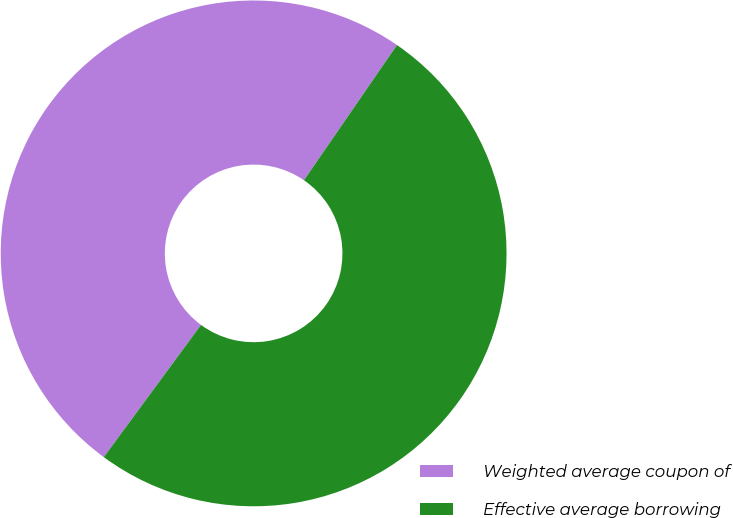<chart> <loc_0><loc_0><loc_500><loc_500><pie_chart><fcel>Weighted average coupon of<fcel>Effective average borrowing<nl><fcel>49.5%<fcel>50.5%<nl></chart> 